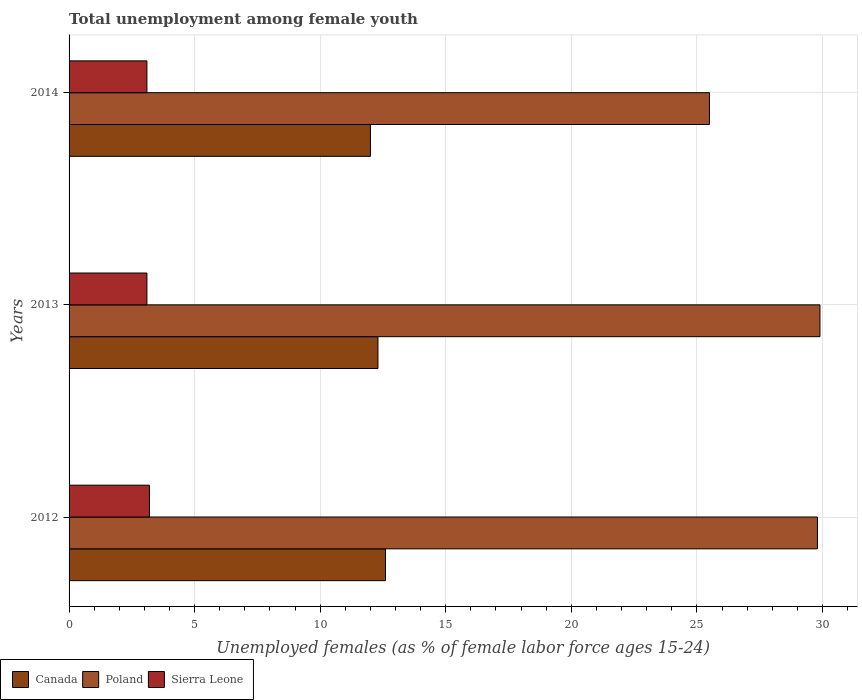How many groups of bars are there?
Provide a short and direct response. 3. Are the number of bars per tick equal to the number of legend labels?
Your response must be concise. Yes. How many bars are there on the 1st tick from the top?
Give a very brief answer. 3. In how many cases, is the number of bars for a given year not equal to the number of legend labels?
Your response must be concise. 0. What is the percentage of unemployed females in in Sierra Leone in 2012?
Keep it short and to the point. 3.2. Across all years, what is the maximum percentage of unemployed females in in Canada?
Provide a short and direct response. 12.6. In which year was the percentage of unemployed females in in Sierra Leone minimum?
Ensure brevity in your answer.  2013. What is the total percentage of unemployed females in in Sierra Leone in the graph?
Your response must be concise. 9.4. What is the difference between the percentage of unemployed females in in Canada in 2013 and that in 2014?
Make the answer very short. 0.3. What is the difference between the percentage of unemployed females in in Canada in 2013 and the percentage of unemployed females in in Sierra Leone in 2012?
Offer a very short reply. 9.1. What is the average percentage of unemployed females in in Sierra Leone per year?
Make the answer very short. 3.13. In the year 2012, what is the difference between the percentage of unemployed females in in Canada and percentage of unemployed females in in Sierra Leone?
Make the answer very short. 9.4. What is the ratio of the percentage of unemployed females in in Poland in 2012 to that in 2013?
Keep it short and to the point. 1. What is the difference between the highest and the second highest percentage of unemployed females in in Poland?
Give a very brief answer. 0.1. What is the difference between the highest and the lowest percentage of unemployed females in in Poland?
Your answer should be very brief. 4.4. Is the sum of the percentage of unemployed females in in Poland in 2012 and 2014 greater than the maximum percentage of unemployed females in in Canada across all years?
Make the answer very short. Yes. What does the 3rd bar from the top in 2012 represents?
Offer a very short reply. Canada. How many bars are there?
Your response must be concise. 9. How many years are there in the graph?
Ensure brevity in your answer.  3. Does the graph contain any zero values?
Give a very brief answer. No. Does the graph contain grids?
Make the answer very short. Yes. Where does the legend appear in the graph?
Keep it short and to the point. Bottom left. What is the title of the graph?
Your response must be concise. Total unemployment among female youth. What is the label or title of the X-axis?
Your response must be concise. Unemployed females (as % of female labor force ages 15-24). What is the label or title of the Y-axis?
Offer a very short reply. Years. What is the Unemployed females (as % of female labor force ages 15-24) of Canada in 2012?
Give a very brief answer. 12.6. What is the Unemployed females (as % of female labor force ages 15-24) in Poland in 2012?
Your answer should be very brief. 29.8. What is the Unemployed females (as % of female labor force ages 15-24) in Sierra Leone in 2012?
Your answer should be very brief. 3.2. What is the Unemployed females (as % of female labor force ages 15-24) of Canada in 2013?
Your response must be concise. 12.3. What is the Unemployed females (as % of female labor force ages 15-24) of Poland in 2013?
Your answer should be compact. 29.9. What is the Unemployed females (as % of female labor force ages 15-24) of Sierra Leone in 2013?
Keep it short and to the point. 3.1. What is the Unemployed females (as % of female labor force ages 15-24) of Canada in 2014?
Ensure brevity in your answer.  12. What is the Unemployed females (as % of female labor force ages 15-24) of Poland in 2014?
Give a very brief answer. 25.5. What is the Unemployed females (as % of female labor force ages 15-24) of Sierra Leone in 2014?
Provide a short and direct response. 3.1. Across all years, what is the maximum Unemployed females (as % of female labor force ages 15-24) in Canada?
Provide a short and direct response. 12.6. Across all years, what is the maximum Unemployed females (as % of female labor force ages 15-24) of Poland?
Your response must be concise. 29.9. Across all years, what is the maximum Unemployed females (as % of female labor force ages 15-24) of Sierra Leone?
Keep it short and to the point. 3.2. Across all years, what is the minimum Unemployed females (as % of female labor force ages 15-24) of Sierra Leone?
Give a very brief answer. 3.1. What is the total Unemployed females (as % of female labor force ages 15-24) in Canada in the graph?
Make the answer very short. 36.9. What is the total Unemployed females (as % of female labor force ages 15-24) in Poland in the graph?
Keep it short and to the point. 85.2. What is the total Unemployed females (as % of female labor force ages 15-24) of Sierra Leone in the graph?
Ensure brevity in your answer.  9.4. What is the difference between the Unemployed females (as % of female labor force ages 15-24) in Canada in 2012 and that in 2013?
Give a very brief answer. 0.3. What is the difference between the Unemployed females (as % of female labor force ages 15-24) in Poland in 2012 and that in 2013?
Provide a short and direct response. -0.1. What is the difference between the Unemployed females (as % of female labor force ages 15-24) of Canada in 2012 and that in 2014?
Offer a terse response. 0.6. What is the difference between the Unemployed females (as % of female labor force ages 15-24) in Poland in 2012 and that in 2014?
Provide a short and direct response. 4.3. What is the difference between the Unemployed females (as % of female labor force ages 15-24) of Sierra Leone in 2012 and that in 2014?
Your answer should be compact. 0.1. What is the difference between the Unemployed females (as % of female labor force ages 15-24) in Canada in 2012 and the Unemployed females (as % of female labor force ages 15-24) in Poland in 2013?
Offer a terse response. -17.3. What is the difference between the Unemployed females (as % of female labor force ages 15-24) in Canada in 2012 and the Unemployed females (as % of female labor force ages 15-24) in Sierra Leone in 2013?
Your response must be concise. 9.5. What is the difference between the Unemployed females (as % of female labor force ages 15-24) of Poland in 2012 and the Unemployed females (as % of female labor force ages 15-24) of Sierra Leone in 2013?
Provide a short and direct response. 26.7. What is the difference between the Unemployed females (as % of female labor force ages 15-24) of Canada in 2012 and the Unemployed females (as % of female labor force ages 15-24) of Sierra Leone in 2014?
Make the answer very short. 9.5. What is the difference between the Unemployed females (as % of female labor force ages 15-24) in Poland in 2012 and the Unemployed females (as % of female labor force ages 15-24) in Sierra Leone in 2014?
Ensure brevity in your answer.  26.7. What is the difference between the Unemployed females (as % of female labor force ages 15-24) of Canada in 2013 and the Unemployed females (as % of female labor force ages 15-24) of Poland in 2014?
Give a very brief answer. -13.2. What is the difference between the Unemployed females (as % of female labor force ages 15-24) in Poland in 2013 and the Unemployed females (as % of female labor force ages 15-24) in Sierra Leone in 2014?
Provide a succinct answer. 26.8. What is the average Unemployed females (as % of female labor force ages 15-24) of Canada per year?
Your answer should be very brief. 12.3. What is the average Unemployed females (as % of female labor force ages 15-24) of Poland per year?
Provide a short and direct response. 28.4. What is the average Unemployed females (as % of female labor force ages 15-24) in Sierra Leone per year?
Your response must be concise. 3.13. In the year 2012, what is the difference between the Unemployed females (as % of female labor force ages 15-24) in Canada and Unemployed females (as % of female labor force ages 15-24) in Poland?
Your response must be concise. -17.2. In the year 2012, what is the difference between the Unemployed females (as % of female labor force ages 15-24) in Canada and Unemployed females (as % of female labor force ages 15-24) in Sierra Leone?
Keep it short and to the point. 9.4. In the year 2012, what is the difference between the Unemployed females (as % of female labor force ages 15-24) in Poland and Unemployed females (as % of female labor force ages 15-24) in Sierra Leone?
Make the answer very short. 26.6. In the year 2013, what is the difference between the Unemployed females (as % of female labor force ages 15-24) in Canada and Unemployed females (as % of female labor force ages 15-24) in Poland?
Your response must be concise. -17.6. In the year 2013, what is the difference between the Unemployed females (as % of female labor force ages 15-24) of Canada and Unemployed females (as % of female labor force ages 15-24) of Sierra Leone?
Your answer should be very brief. 9.2. In the year 2013, what is the difference between the Unemployed females (as % of female labor force ages 15-24) of Poland and Unemployed females (as % of female labor force ages 15-24) of Sierra Leone?
Your response must be concise. 26.8. In the year 2014, what is the difference between the Unemployed females (as % of female labor force ages 15-24) of Canada and Unemployed females (as % of female labor force ages 15-24) of Poland?
Your response must be concise. -13.5. In the year 2014, what is the difference between the Unemployed females (as % of female labor force ages 15-24) in Canada and Unemployed females (as % of female labor force ages 15-24) in Sierra Leone?
Give a very brief answer. 8.9. In the year 2014, what is the difference between the Unemployed females (as % of female labor force ages 15-24) in Poland and Unemployed females (as % of female labor force ages 15-24) in Sierra Leone?
Provide a short and direct response. 22.4. What is the ratio of the Unemployed females (as % of female labor force ages 15-24) of Canada in 2012 to that in 2013?
Provide a succinct answer. 1.02. What is the ratio of the Unemployed females (as % of female labor force ages 15-24) in Sierra Leone in 2012 to that in 2013?
Your answer should be very brief. 1.03. What is the ratio of the Unemployed females (as % of female labor force ages 15-24) in Canada in 2012 to that in 2014?
Ensure brevity in your answer.  1.05. What is the ratio of the Unemployed females (as % of female labor force ages 15-24) of Poland in 2012 to that in 2014?
Offer a very short reply. 1.17. What is the ratio of the Unemployed females (as % of female labor force ages 15-24) in Sierra Leone in 2012 to that in 2014?
Your answer should be very brief. 1.03. What is the ratio of the Unemployed females (as % of female labor force ages 15-24) in Canada in 2013 to that in 2014?
Offer a terse response. 1.02. What is the ratio of the Unemployed females (as % of female labor force ages 15-24) of Poland in 2013 to that in 2014?
Offer a very short reply. 1.17. What is the difference between the highest and the second highest Unemployed females (as % of female labor force ages 15-24) in Canada?
Offer a terse response. 0.3. What is the difference between the highest and the second highest Unemployed females (as % of female labor force ages 15-24) of Poland?
Provide a succinct answer. 0.1. What is the difference between the highest and the second highest Unemployed females (as % of female labor force ages 15-24) of Sierra Leone?
Ensure brevity in your answer.  0.1. What is the difference between the highest and the lowest Unemployed females (as % of female labor force ages 15-24) of Poland?
Keep it short and to the point. 4.4. What is the difference between the highest and the lowest Unemployed females (as % of female labor force ages 15-24) of Sierra Leone?
Offer a very short reply. 0.1. 